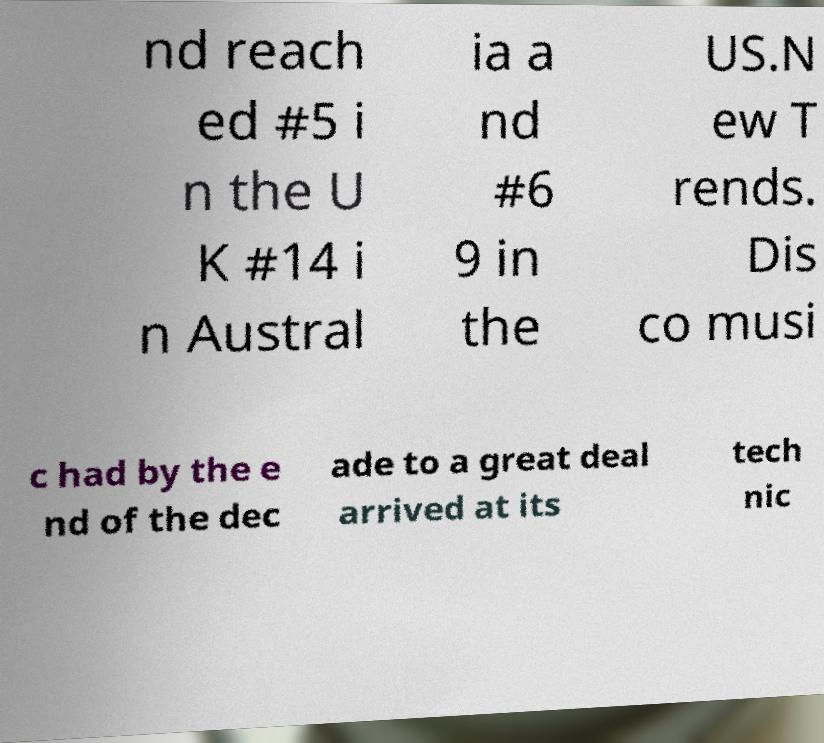Please identify and transcribe the text found in this image. nd reach ed #5 i n the U K #14 i n Austral ia a nd #6 9 in the US.N ew T rends. Dis co musi c had by the e nd of the dec ade to a great deal arrived at its tech nic 